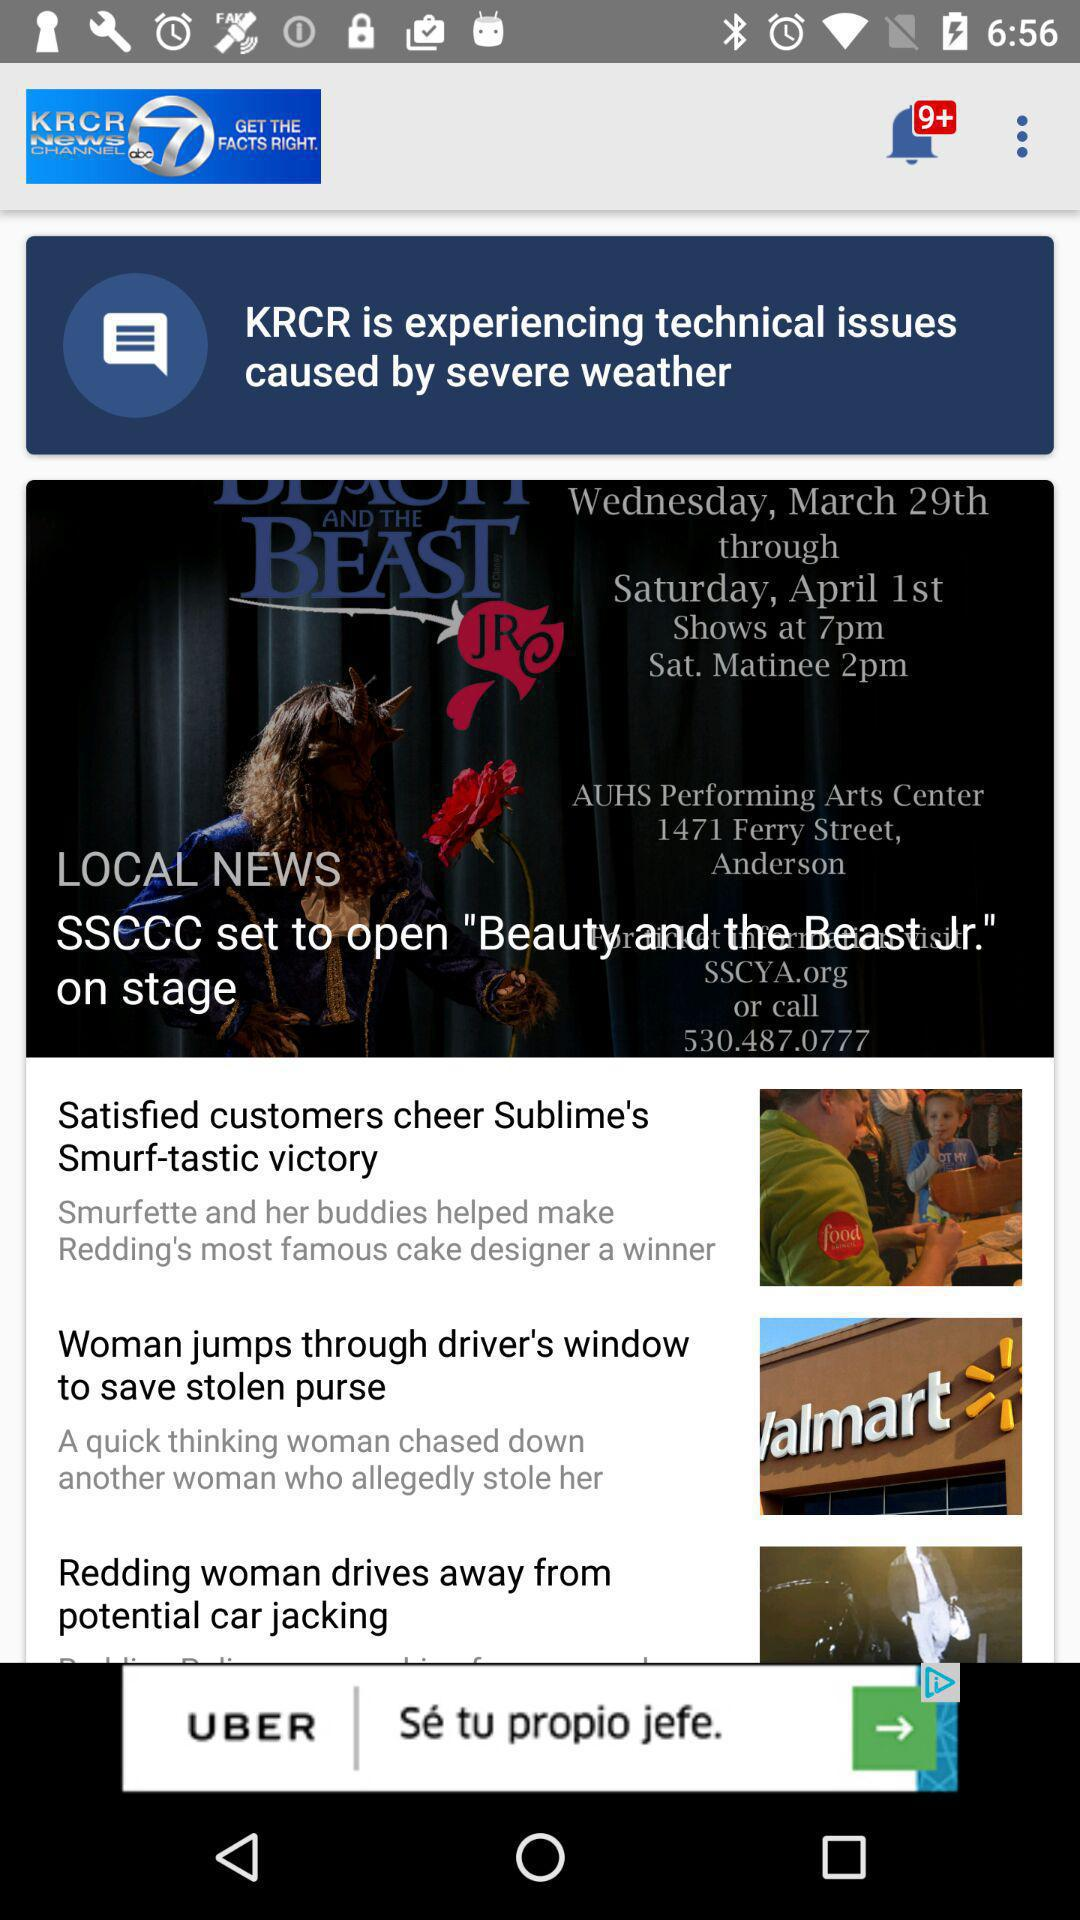How many unread notifications are there? There are more than nine unread notifications. 